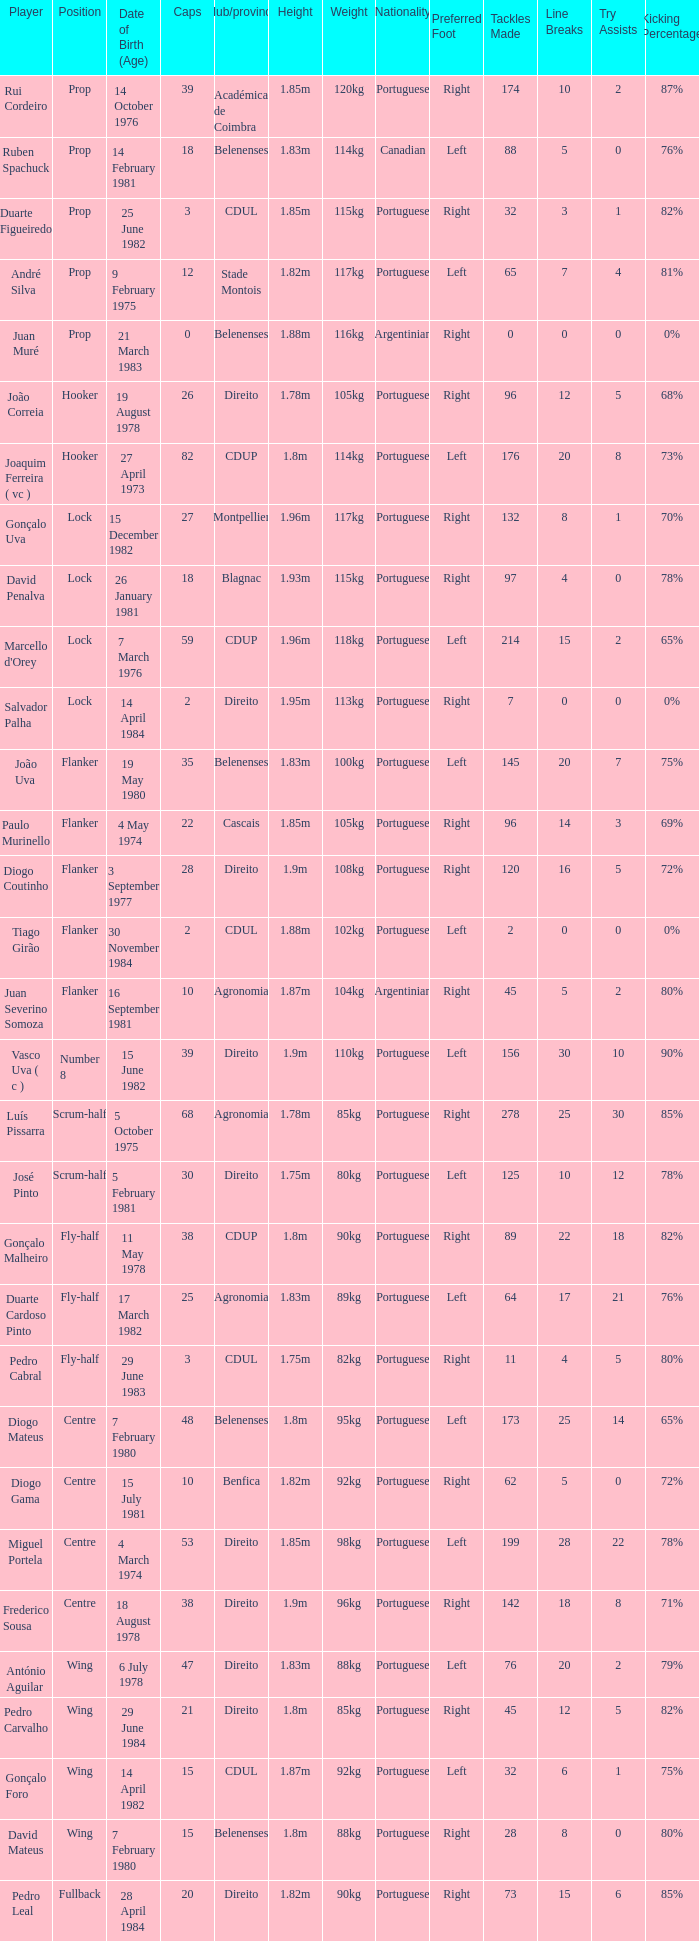Which player has a Club/province of direito, less than 21 caps, and a Position of lock? Salvador Palha. 